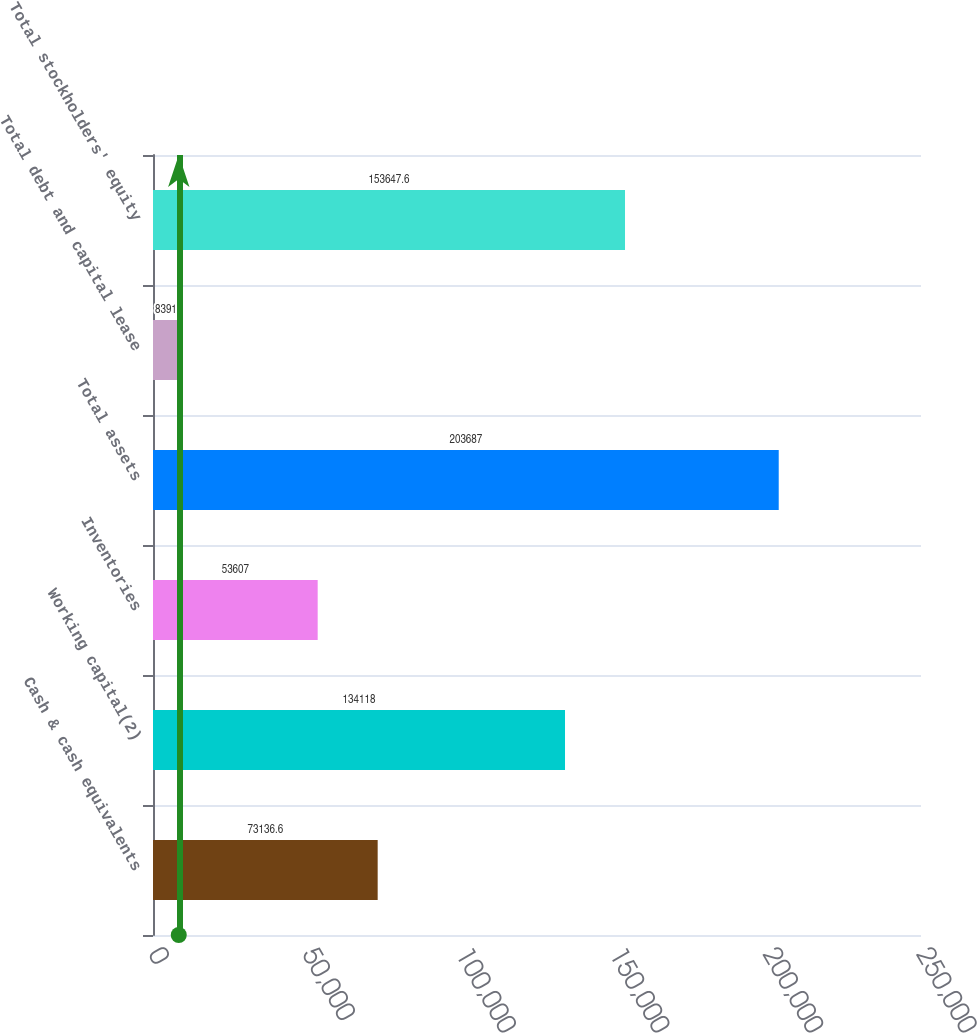<chart> <loc_0><loc_0><loc_500><loc_500><bar_chart><fcel>Cash & cash equivalents<fcel>Working capital(2)<fcel>Inventories<fcel>Total assets<fcel>Total debt and capital lease<fcel>Total stockholders' equity<nl><fcel>73136.6<fcel>134118<fcel>53607<fcel>203687<fcel>8391<fcel>153648<nl></chart> 